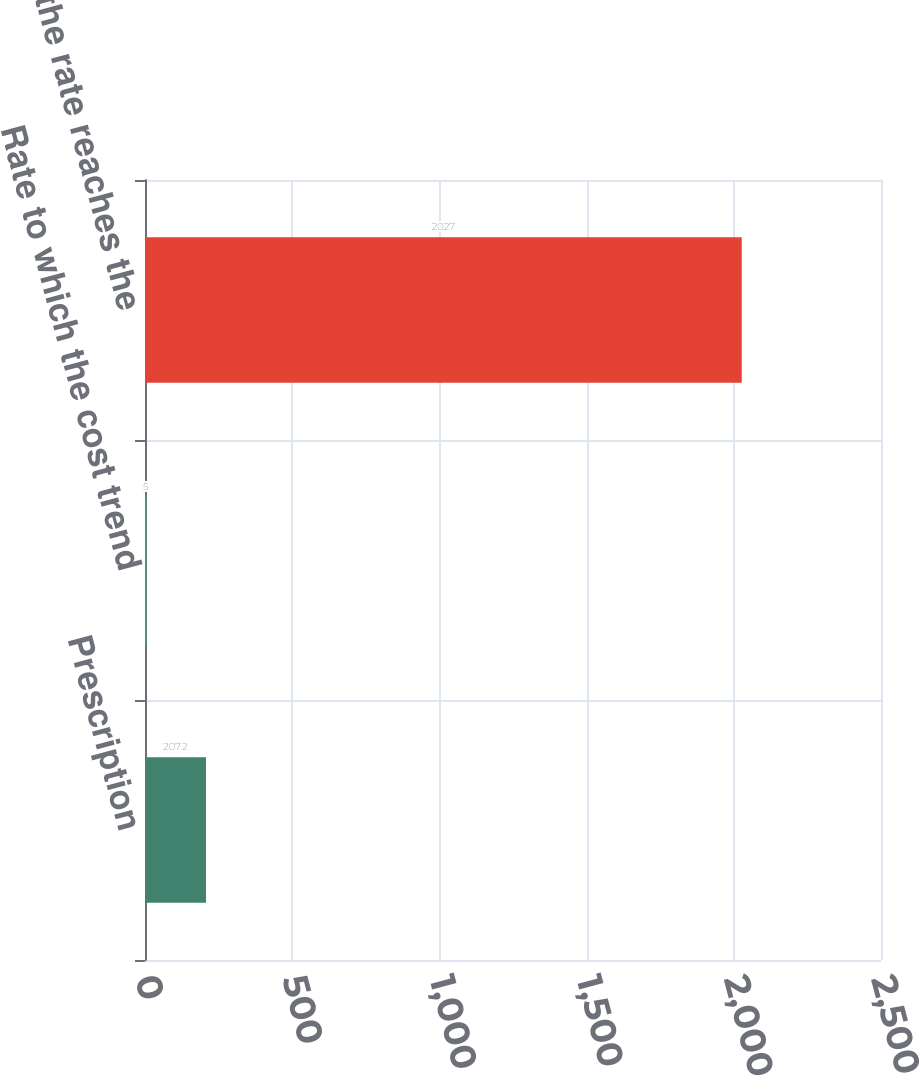Convert chart to OTSL. <chart><loc_0><loc_0><loc_500><loc_500><bar_chart><fcel>Prescription<fcel>Rate to which the cost trend<fcel>Year that the rate reaches the<nl><fcel>207.2<fcel>5<fcel>2027<nl></chart> 